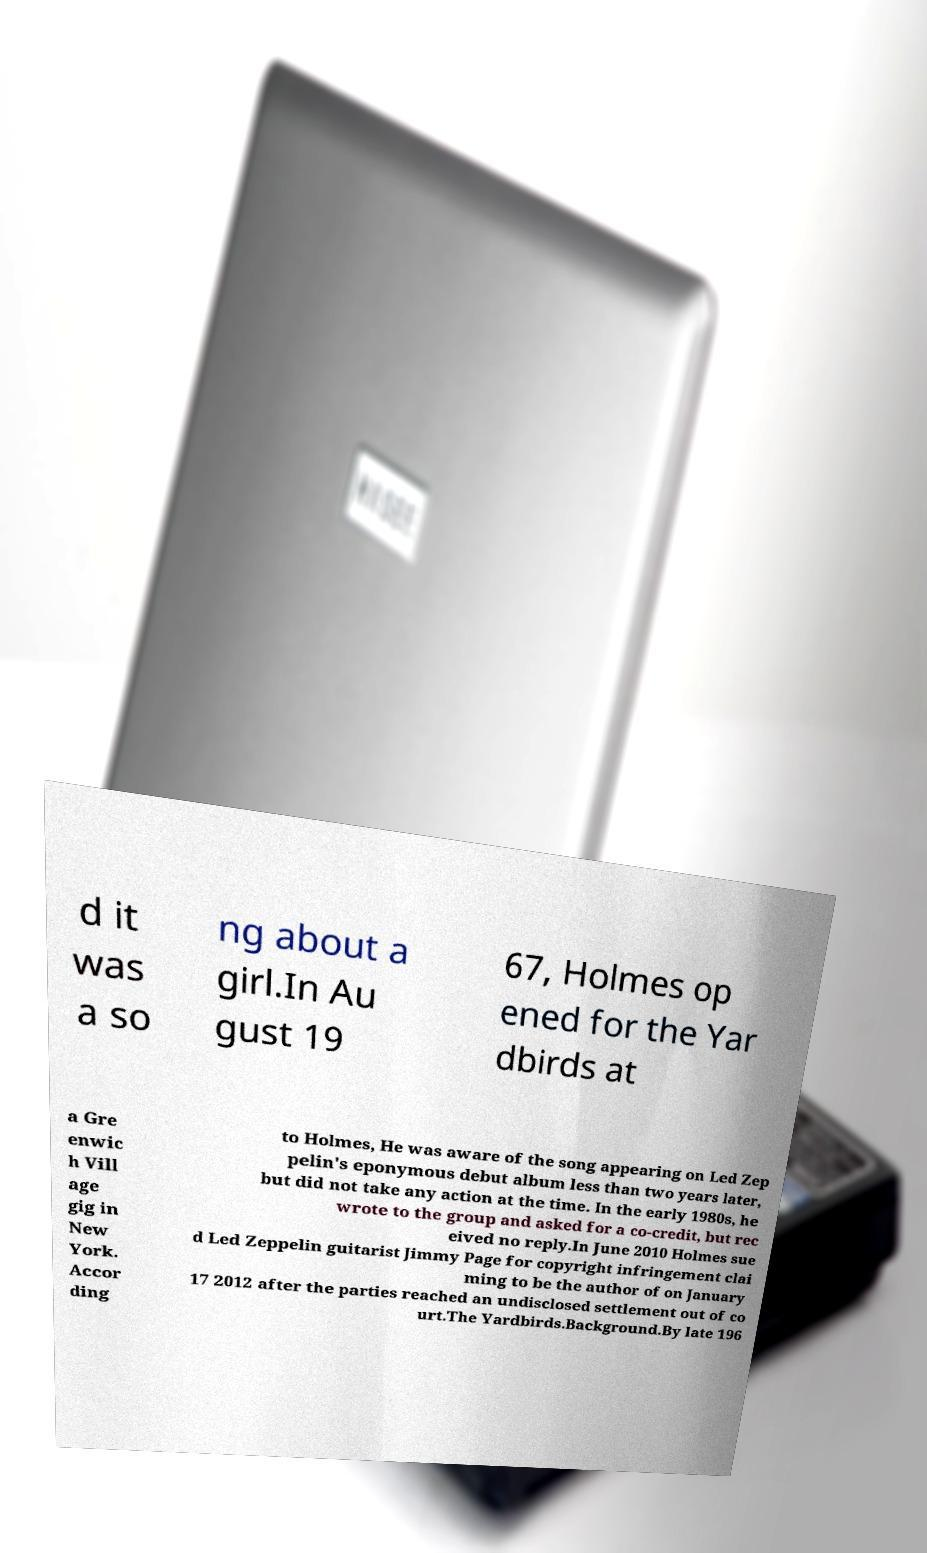Could you assist in decoding the text presented in this image and type it out clearly? d it was a so ng about a girl.In Au gust 19 67, Holmes op ened for the Yar dbirds at a Gre enwic h Vill age gig in New York. Accor ding to Holmes, He was aware of the song appearing on Led Zep pelin's eponymous debut album less than two years later, but did not take any action at the time. In the early 1980s, he wrote to the group and asked for a co-credit, but rec eived no reply.In June 2010 Holmes sue d Led Zeppelin guitarist Jimmy Page for copyright infringement clai ming to be the author of on January 17 2012 after the parties reached an undisclosed settlement out of co urt.The Yardbirds.Background.By late 196 